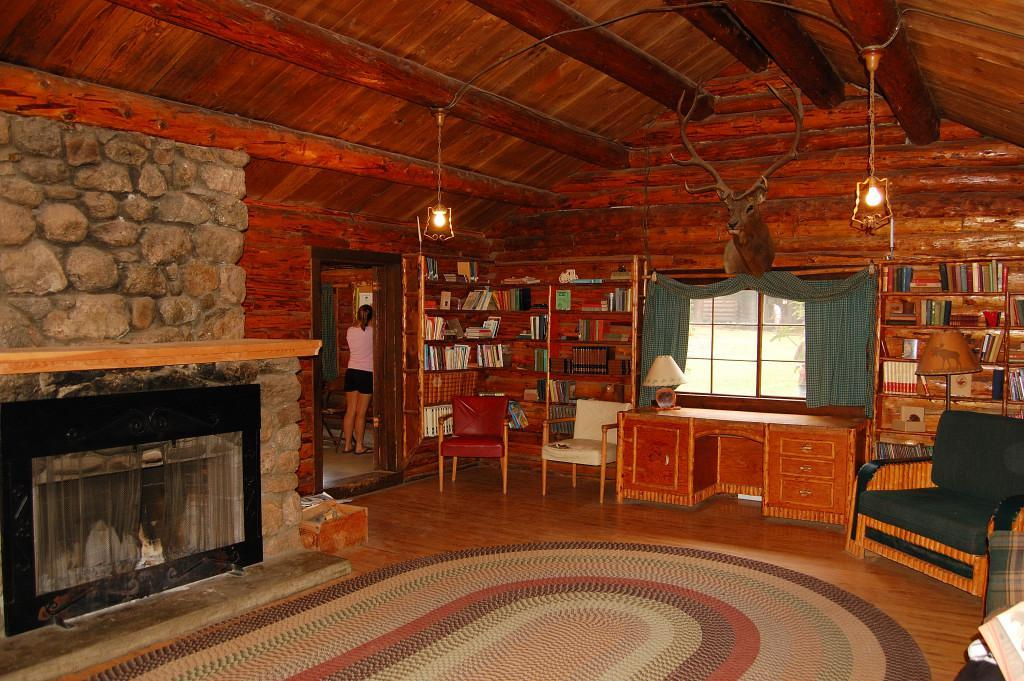What type of furniture is present in the image? There is a chair and a table in the image. What is the purpose of the book rack in the image? The book rack is used for storing books. What can be seen through the window in the image? The window has a curtain associated with it, but the view through the window is not mentioned in the facts. What is the person standing in the image doing? The facts do not specify what the person is doing. What is placed on the floor in the image? There is a floor-mat in the image. What type of underwear is the person wearing in the image? There is no information about the person's clothing in the image, so we cannot determine what type of underwear they might be wearing. Is this a library setting, given the presence of a book rack? The facts do not specify the location or context of the image, so we cannot determine if it is a library setting or not. 